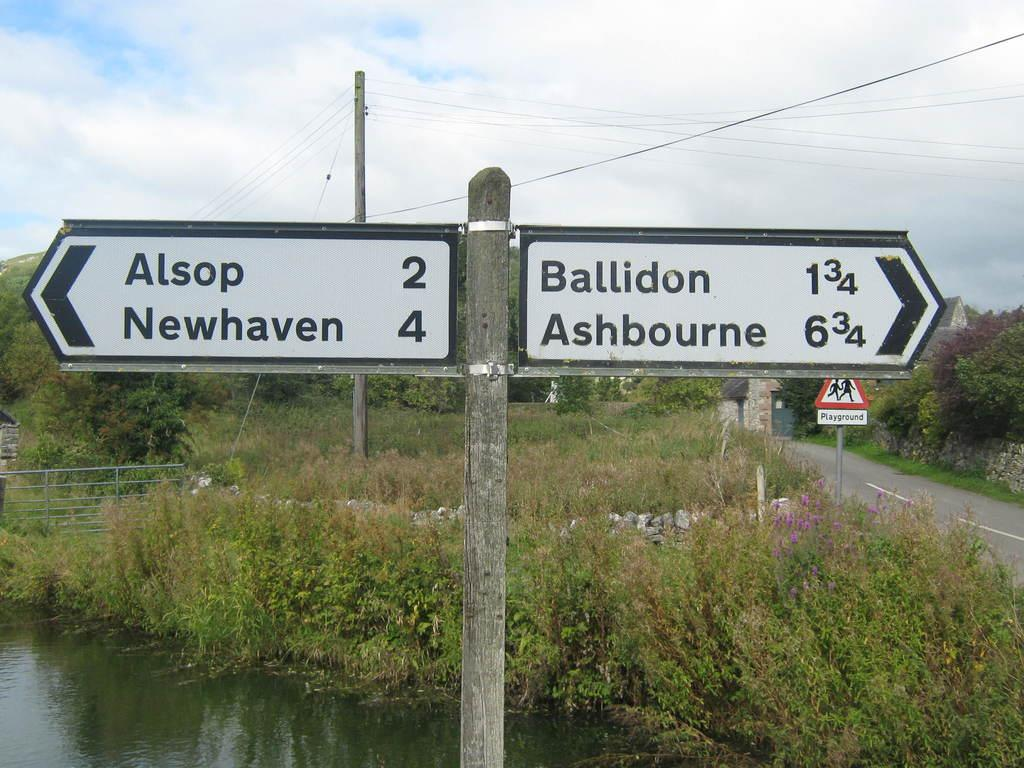<image>
Render a clear and concise summary of the photo. A street sign points that Alsop is to the left and Ashbourne is to the right. 